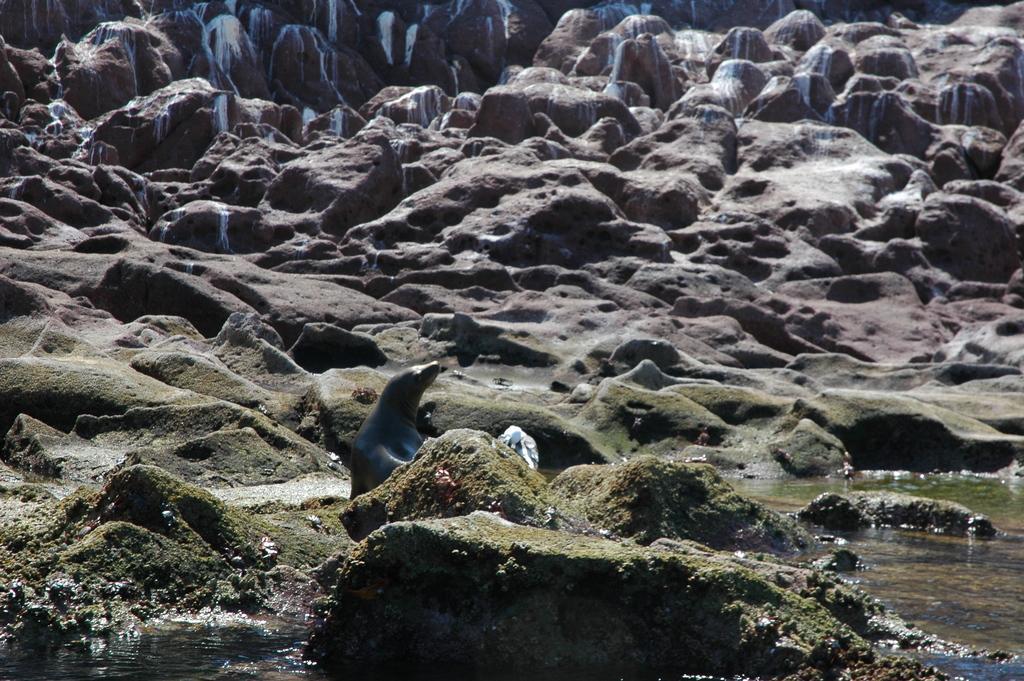Describe this image in one or two sentences. In this image I can see a penguin and water at the bottom ,in the middle I can see the sand and the mountain. 